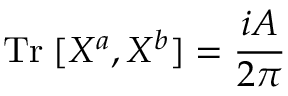Convert formula to latex. <formula><loc_0><loc_0><loc_500><loc_500>T r \, [ X ^ { a } , X ^ { b } ] = \frac { i A } { 2 \pi }</formula> 